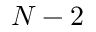Convert formula to latex. <formula><loc_0><loc_0><loc_500><loc_500>N - 2</formula> 